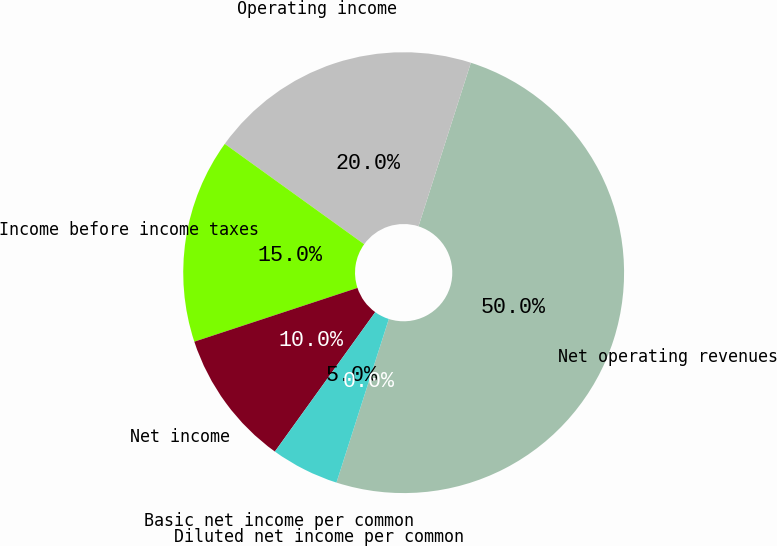Convert chart to OTSL. <chart><loc_0><loc_0><loc_500><loc_500><pie_chart><fcel>Net operating revenues<fcel>Operating income<fcel>Income before income taxes<fcel>Net income<fcel>Basic net income per common<fcel>Diluted net income per common<nl><fcel>50.0%<fcel>20.0%<fcel>15.0%<fcel>10.0%<fcel>5.0%<fcel>0.0%<nl></chart> 